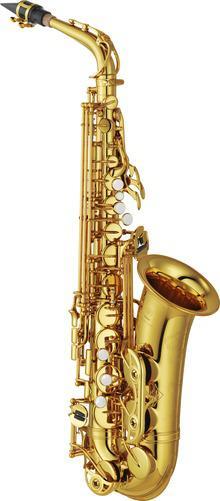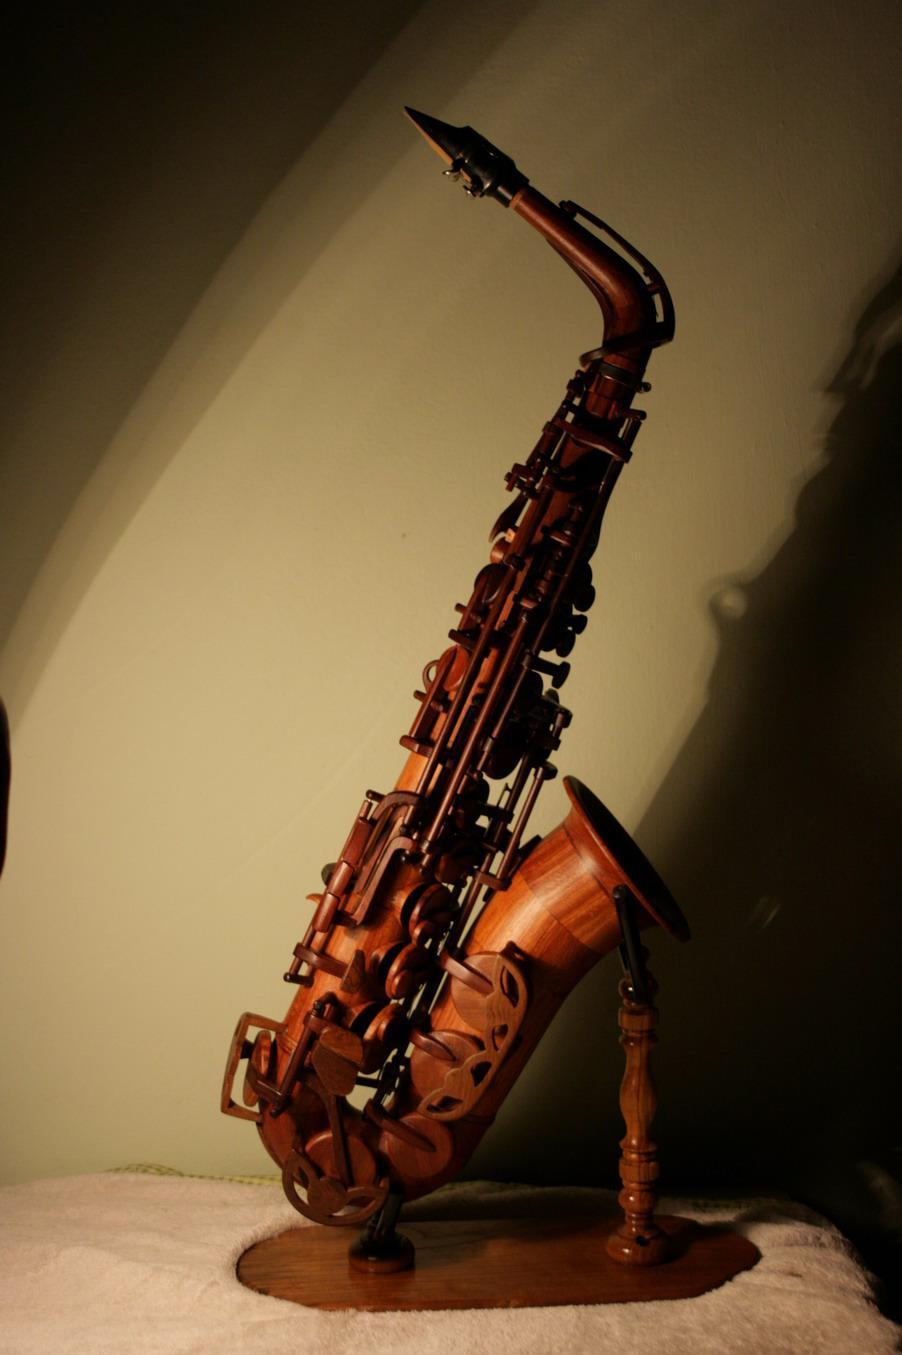The first image is the image on the left, the second image is the image on the right. Analyze the images presented: Is the assertion "The saxophone in the image on the left is on a stand." valid? Answer yes or no. No. The first image is the image on the left, the second image is the image on the right. Considering the images on both sides, is "The left image shows one instrument displayed on a wooden stand." valid? Answer yes or no. No. 